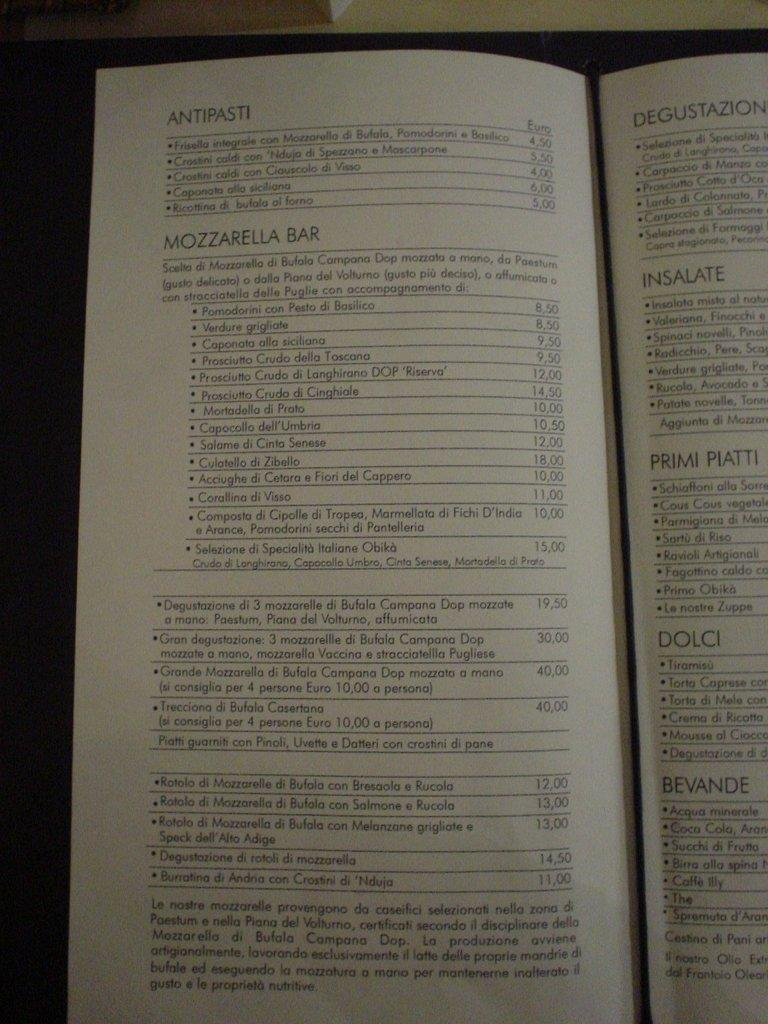<image>
Present a compact description of the photo's key features. A menu opened to several types of dishes including antipasti. 